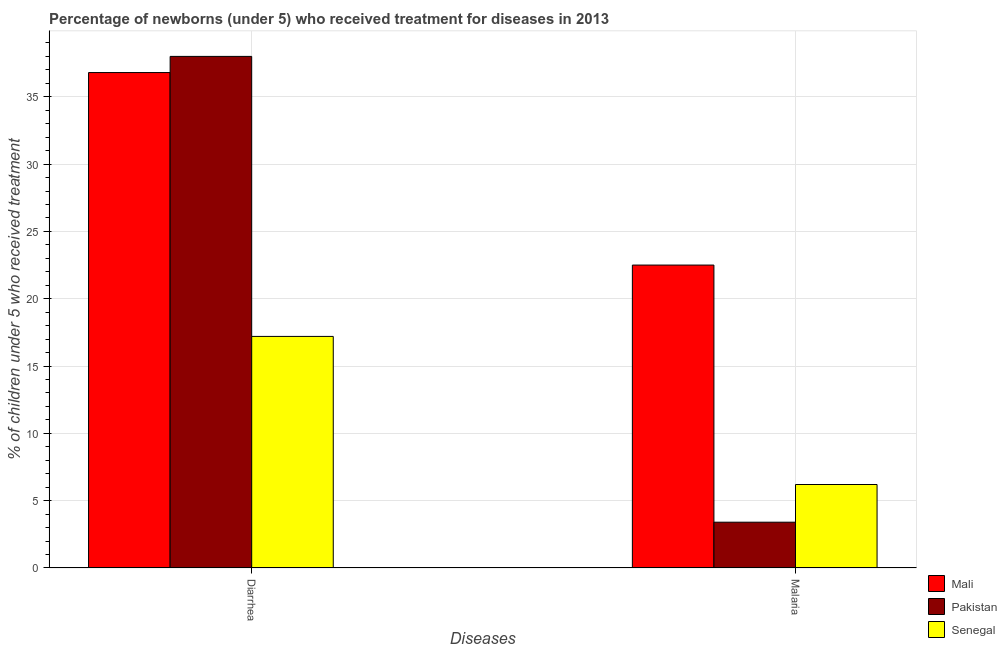How many different coloured bars are there?
Keep it short and to the point. 3. How many groups of bars are there?
Your answer should be very brief. 2. Are the number of bars per tick equal to the number of legend labels?
Offer a terse response. Yes. How many bars are there on the 1st tick from the right?
Your answer should be very brief. 3. What is the label of the 1st group of bars from the left?
Make the answer very short. Diarrhea. What is the percentage of children who received treatment for malaria in Mali?
Keep it short and to the point. 22.5. Across all countries, what is the maximum percentage of children who received treatment for diarrhoea?
Provide a short and direct response. 38. In which country was the percentage of children who received treatment for malaria maximum?
Offer a very short reply. Mali. In which country was the percentage of children who received treatment for malaria minimum?
Ensure brevity in your answer.  Pakistan. What is the total percentage of children who received treatment for diarrhoea in the graph?
Your answer should be very brief. 92. What is the difference between the percentage of children who received treatment for diarrhoea in Mali and that in Senegal?
Your answer should be compact. 19.6. What is the difference between the percentage of children who received treatment for malaria in Pakistan and the percentage of children who received treatment for diarrhoea in Mali?
Offer a very short reply. -33.4. What is the average percentage of children who received treatment for diarrhoea per country?
Offer a very short reply. 30.67. In how many countries, is the percentage of children who received treatment for diarrhoea greater than 20 %?
Provide a succinct answer. 2. What is the ratio of the percentage of children who received treatment for diarrhoea in Pakistan to that in Senegal?
Your answer should be very brief. 2.21. In how many countries, is the percentage of children who received treatment for diarrhoea greater than the average percentage of children who received treatment for diarrhoea taken over all countries?
Keep it short and to the point. 2. Are the values on the major ticks of Y-axis written in scientific E-notation?
Provide a short and direct response. No. Does the graph contain grids?
Ensure brevity in your answer.  Yes. How many legend labels are there?
Offer a very short reply. 3. How are the legend labels stacked?
Keep it short and to the point. Vertical. What is the title of the graph?
Offer a terse response. Percentage of newborns (under 5) who received treatment for diseases in 2013. Does "Low income" appear as one of the legend labels in the graph?
Provide a succinct answer. No. What is the label or title of the X-axis?
Your answer should be very brief. Diseases. What is the label or title of the Y-axis?
Provide a succinct answer. % of children under 5 who received treatment. What is the % of children under 5 who received treatment in Mali in Diarrhea?
Ensure brevity in your answer.  36.8. What is the % of children under 5 who received treatment of Senegal in Diarrhea?
Your answer should be very brief. 17.2. What is the % of children under 5 who received treatment of Mali in Malaria?
Provide a succinct answer. 22.5. Across all Diseases, what is the maximum % of children under 5 who received treatment of Mali?
Keep it short and to the point. 36.8. Across all Diseases, what is the maximum % of children under 5 who received treatment of Senegal?
Make the answer very short. 17.2. What is the total % of children under 5 who received treatment of Mali in the graph?
Offer a terse response. 59.3. What is the total % of children under 5 who received treatment in Pakistan in the graph?
Your answer should be compact. 41.4. What is the total % of children under 5 who received treatment of Senegal in the graph?
Your answer should be very brief. 23.4. What is the difference between the % of children under 5 who received treatment of Mali in Diarrhea and that in Malaria?
Ensure brevity in your answer.  14.3. What is the difference between the % of children under 5 who received treatment in Pakistan in Diarrhea and that in Malaria?
Offer a very short reply. 34.6. What is the difference between the % of children under 5 who received treatment in Mali in Diarrhea and the % of children under 5 who received treatment in Pakistan in Malaria?
Give a very brief answer. 33.4. What is the difference between the % of children under 5 who received treatment in Mali in Diarrhea and the % of children under 5 who received treatment in Senegal in Malaria?
Give a very brief answer. 30.6. What is the difference between the % of children under 5 who received treatment of Pakistan in Diarrhea and the % of children under 5 who received treatment of Senegal in Malaria?
Your answer should be very brief. 31.8. What is the average % of children under 5 who received treatment in Mali per Diseases?
Provide a succinct answer. 29.65. What is the average % of children under 5 who received treatment in Pakistan per Diseases?
Provide a short and direct response. 20.7. What is the difference between the % of children under 5 who received treatment in Mali and % of children under 5 who received treatment in Senegal in Diarrhea?
Keep it short and to the point. 19.6. What is the difference between the % of children under 5 who received treatment of Pakistan and % of children under 5 who received treatment of Senegal in Diarrhea?
Ensure brevity in your answer.  20.8. What is the difference between the % of children under 5 who received treatment in Mali and % of children under 5 who received treatment in Senegal in Malaria?
Provide a short and direct response. 16.3. What is the ratio of the % of children under 5 who received treatment in Mali in Diarrhea to that in Malaria?
Make the answer very short. 1.64. What is the ratio of the % of children under 5 who received treatment in Pakistan in Diarrhea to that in Malaria?
Offer a very short reply. 11.18. What is the ratio of the % of children under 5 who received treatment of Senegal in Diarrhea to that in Malaria?
Offer a very short reply. 2.77. What is the difference between the highest and the second highest % of children under 5 who received treatment in Mali?
Keep it short and to the point. 14.3. What is the difference between the highest and the second highest % of children under 5 who received treatment of Pakistan?
Provide a short and direct response. 34.6. What is the difference between the highest and the second highest % of children under 5 who received treatment in Senegal?
Your answer should be compact. 11. What is the difference between the highest and the lowest % of children under 5 who received treatment in Mali?
Offer a very short reply. 14.3. What is the difference between the highest and the lowest % of children under 5 who received treatment in Pakistan?
Your answer should be compact. 34.6. What is the difference between the highest and the lowest % of children under 5 who received treatment of Senegal?
Offer a terse response. 11. 